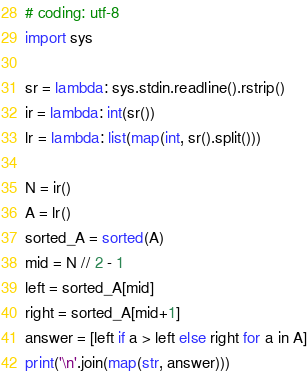Convert code to text. <code><loc_0><loc_0><loc_500><loc_500><_Python_># coding: utf-8
import sys

sr = lambda: sys.stdin.readline().rstrip()
ir = lambda: int(sr())
lr = lambda: list(map(int, sr().split()))

N = ir()
A = lr()
sorted_A = sorted(A)
mid = N // 2 - 1
left = sorted_A[mid]
right = sorted_A[mid+1]
answer = [left if a > left else right for a in A]
print('\n'.join(map(str, answer)))
</code> 